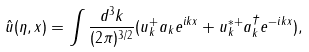Convert formula to latex. <formula><loc_0><loc_0><loc_500><loc_500>{ \hat { u } } ( \eta , { x } ) = \int \frac { d ^ { 3 } k } { ( 2 \pi ) ^ { 3 / 2 } } ( u _ { k } ^ { + } a _ { k } e ^ { i k x } + u _ { k } ^ { * + } a _ { k } ^ { \dagger } e ^ { - i k x } ) ,</formula> 